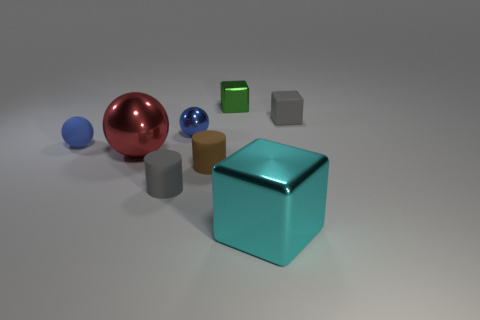There is a cyan metal thing; does it have the same shape as the small gray rubber object that is behind the large red ball?
Make the answer very short. Yes. Is the number of shiny things in front of the red object greater than the number of big brown blocks?
Ensure brevity in your answer.  Yes. Is the number of gray blocks in front of the matte block less than the number of large purple cylinders?
Provide a short and direct response. No. How many metallic balls have the same color as the small rubber sphere?
Make the answer very short. 1. What is the material of the small thing that is both in front of the large red ball and behind the small gray matte cylinder?
Offer a very short reply. Rubber. Does the object on the left side of the big red metal ball have the same color as the small sphere that is to the right of the blue rubber sphere?
Your response must be concise. Yes. What number of cyan things are tiny cylinders or big things?
Ensure brevity in your answer.  1. Is the number of metal blocks behind the big ball less than the number of blue things that are in front of the tiny green thing?
Offer a very short reply. Yes. Is there a brown matte cylinder of the same size as the blue metal ball?
Make the answer very short. Yes. Is the size of the gray rubber object to the right of the green cube the same as the tiny green block?
Provide a short and direct response. Yes. 